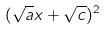<formula> <loc_0><loc_0><loc_500><loc_500>( \sqrt { a } x + \sqrt { c } ) ^ { 2 }</formula> 